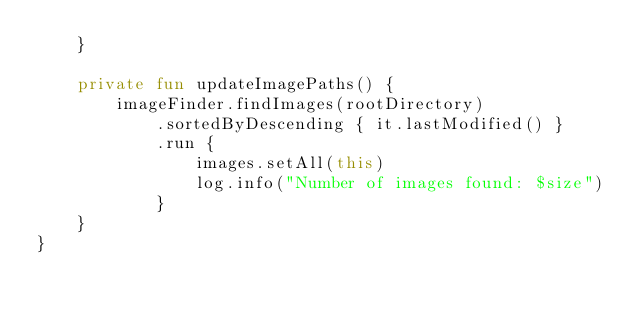<code> <loc_0><loc_0><loc_500><loc_500><_Kotlin_>    }

    private fun updateImagePaths() {
        imageFinder.findImages(rootDirectory)
            .sortedByDescending { it.lastModified() }
            .run {
                images.setAll(this)
                log.info("Number of images found: $size")
            }
    }
}
</code> 